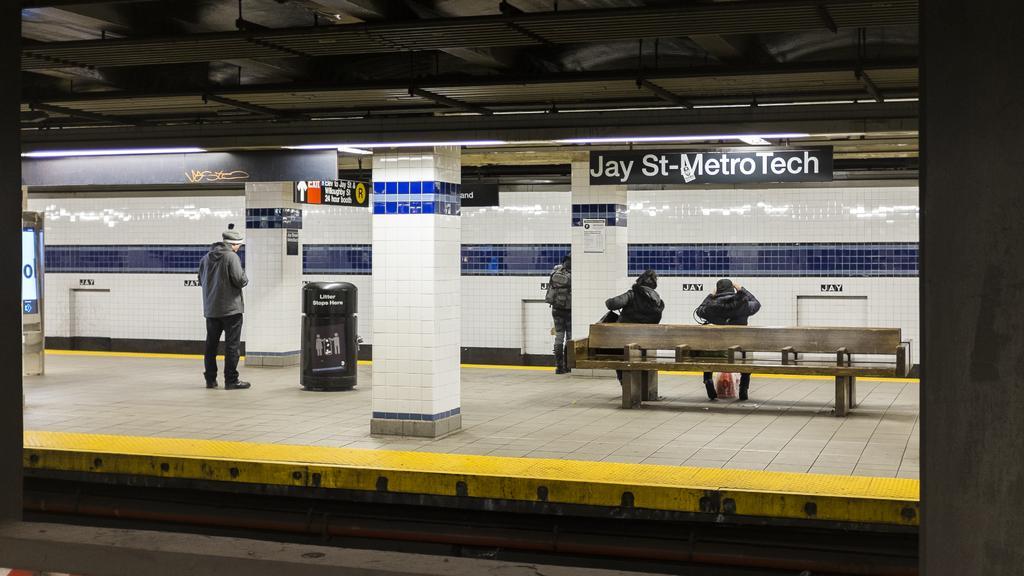Describe this image in one or two sentences. The picture consists of a platform, on the platforms there are benches, people and dustbin. In the background there is a wall with white and blue tiles. At the top there are lights and station board. At the bottom there is a railway track. 